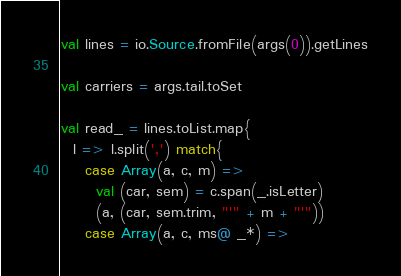<code> <loc_0><loc_0><loc_500><loc_500><_Scala_>val lines = io.Source.fromFile(args(0)).getLines

val carriers = args.tail.toSet
  
val read_ = lines.toList.map{
  l => l.split(',') match{
    case Array(a, c, m) =>
      val (car, sem) = c.span(_.isLetter)
      (a, (car, sem.trim, "'" + m + "'"))
    case Array(a, c, ms@ _*) =></code> 